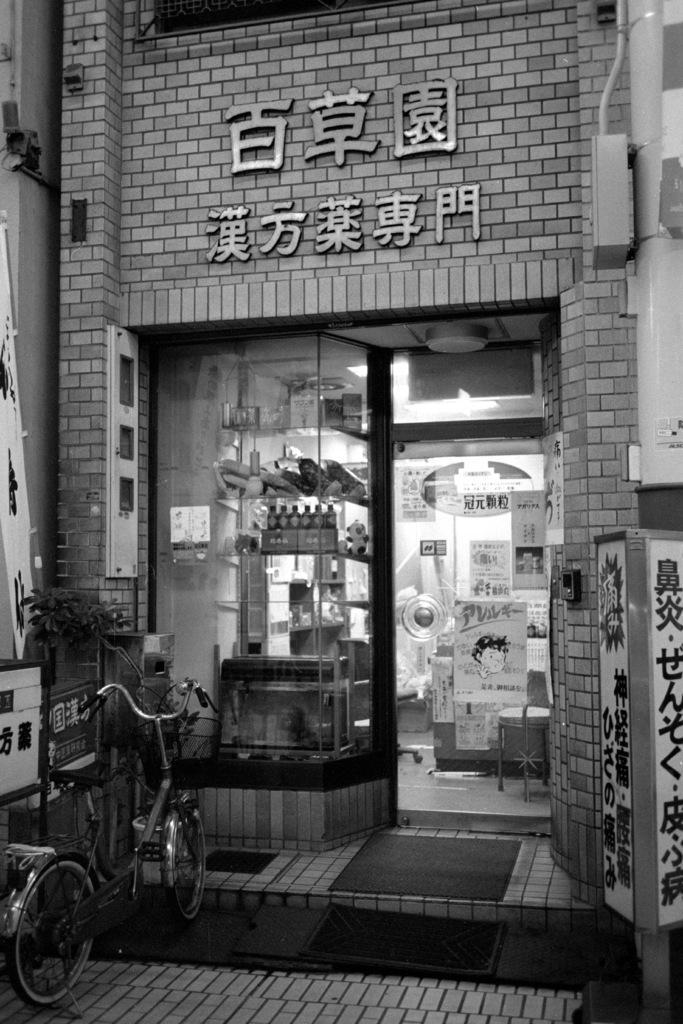Describe this image in one or two sentences. This is a black and white picture. I can see a bicycle, there are mats, there is a shop, there are papers to the glass door, and in the background there are some objects. 